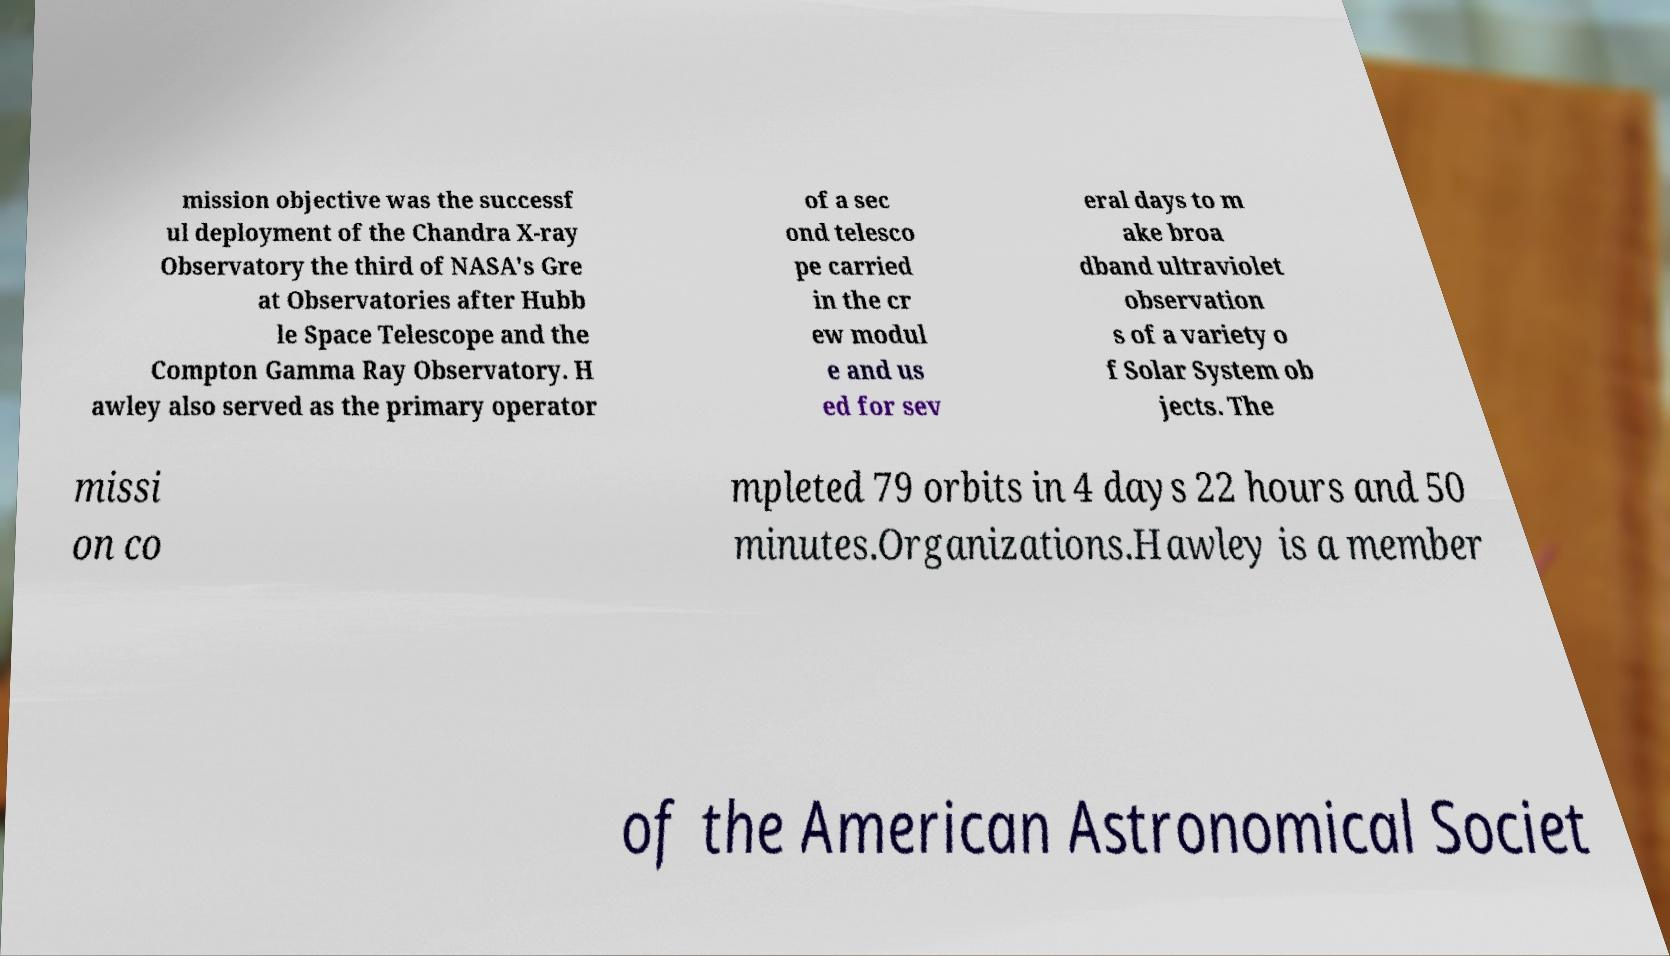Please identify and transcribe the text found in this image. mission objective was the successf ul deployment of the Chandra X-ray Observatory the third of NASA's Gre at Observatories after Hubb le Space Telescope and the Compton Gamma Ray Observatory. H awley also served as the primary operator of a sec ond telesco pe carried in the cr ew modul e and us ed for sev eral days to m ake broa dband ultraviolet observation s of a variety o f Solar System ob jects. The missi on co mpleted 79 orbits in 4 days 22 hours and 50 minutes.Organizations.Hawley is a member of the American Astronomical Societ 